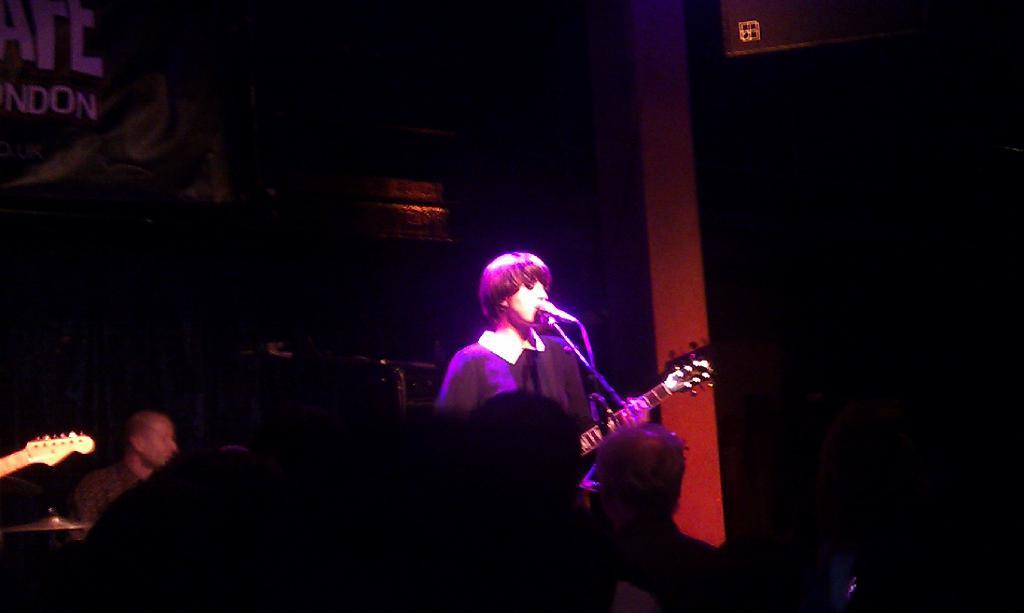What is the man in the image doing? The man is playing guitar and singing in the image. How is the man amplifying his voice? The man is using a microphone in the image. Can you describe the position of the seated man in the image? There is a seated man in the image. What can be seen in the front of the image? There are audience members in the front of the image. How does the man sneeze while playing the guitar in the image? The man is not sneezing in the image; he is playing guitar and singing. 